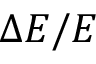Convert formula to latex. <formula><loc_0><loc_0><loc_500><loc_500>\Delta E / E</formula> 